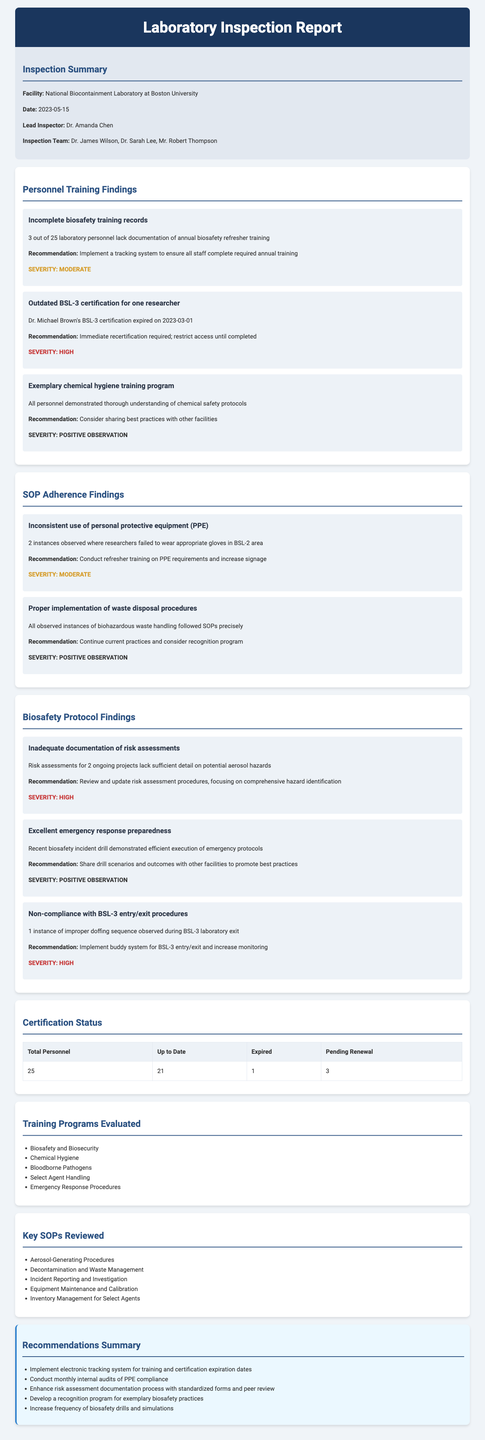What is the name of the facility inspected? The facility name is provided in the inspection summary section.
Answer: National Biocontainment Laboratory at Boston University Who was the lead inspector for this inspection? The document lists the name of the lead inspector in the inspection summary section.
Answer: Dr. Amanda Chen How many laboratory personnel are up to date with their certification? The certification status section specifies how many personnel have current certifications.
Answer: 21 What was the severity level of the finding regarding incomplete biosafety training records? The severity of each finding is indicated in the findings section, specifically for the biosafety training records.
Answer: Moderate What percentage of personnel lack documentation of annual biosafety refresher training? The report states that 3 out of 25 personnel lack documentation, which requires calculating the percentage.
Answer: 12% What recommendation was made regarding Dr. Michael Brown's certification? The document explicitly details the recommendation related to Dr. Michael Brown's expired certification.
Answer: Immediate recertification required; restrict access until completed Which training program had all personnel demonstrate a thorough understanding? This aspect is highlighted in the personnel training findings section, mentioning the training program where understanding was exemplary.
Answer: Chemical hygiene training program What event demonstrated excellent emergency response preparedness? The document describes an event that showcased the facility's preparedness in the biosafety protocol findings section.
Answer: Recent biosafety incident drill 